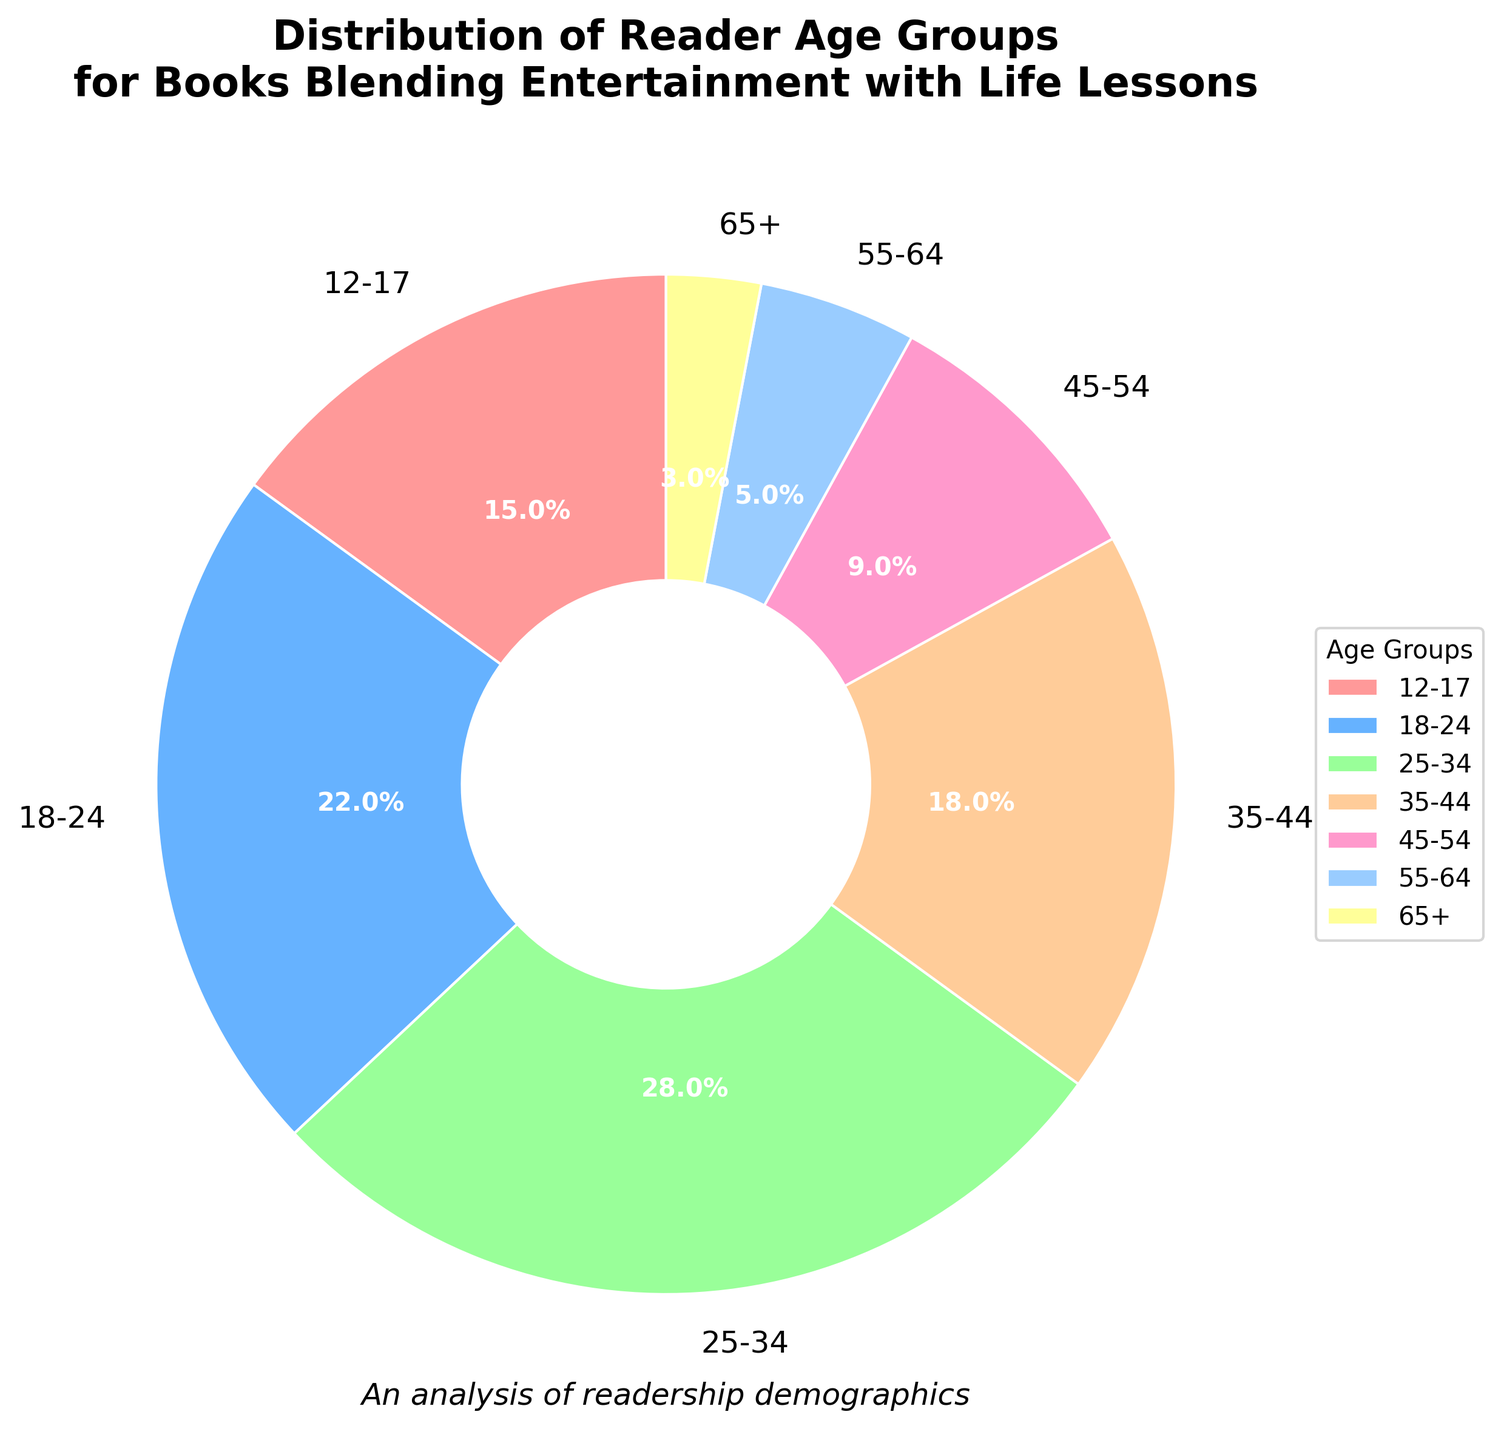What is the most represented age group in the chart? Look at the chart and identify the age group with the largest segment. The largest segment represents the 25-34 age group.
Answer: 25-34 Which age group has a higher percentage: 18-24 or 35-44? Compare the size of the segments for the 18-24 and 35-44 age groups. The 18-24 age group has a percentage of 22%, whereas the 35-44 age group has 18%. Therefore, 18-24 has a higher percentage.
Answer: 18-24 What is the combined percentage of the 12-17 and 18-24 age groups? To find the combined percentage, add the individual percentages of the 12-17 and 18-24 age groups. That is, 15% + 22% = 37%.
Answer: 37% Which color represents the 55-64 age group? Identify the segment corresponding to the 55-64 age group and check its color. The 55-64 age group is represented by a light blue color.
Answer: Light blue How many age groups have a percentage lower than 10%? Look at the chart and count the segments with percentages less than 10%. The age groups 45-54 (9%), 55-64 (5%), and 65+ (3%) are below 10%. There are 3 such groups.
Answer: 3 By how much does the percentage of the 25-34 age group exceed that of the 45-54 age group? Subtract the percentage of the 45-54 age group from that of the 25-34 age group. That is, 28% - 9% = 19%.
Answer: 19% What percentage of readers are aged 35 or older? Add the percentages of the age groups 35-44, 45-54, 55-64, and 65+. That is, 18% + 9% + 5% + 3% = 35%.
Answer: 35% Which age group has the smallest representation in the chart? Identify the smallest segment in the chart. The smallest segment is for the 65+ age group.
Answer: 65+ Is the percentage of the 25-34 age group more than double that of the 12-17 age group? Double the percentage of the 12-17 age group and compare it to the 25-34 age group. That is, 15% * 2 = 30%. The 25-34 age group has a percentage of 28%, which is less than 30%.
Answer: No 